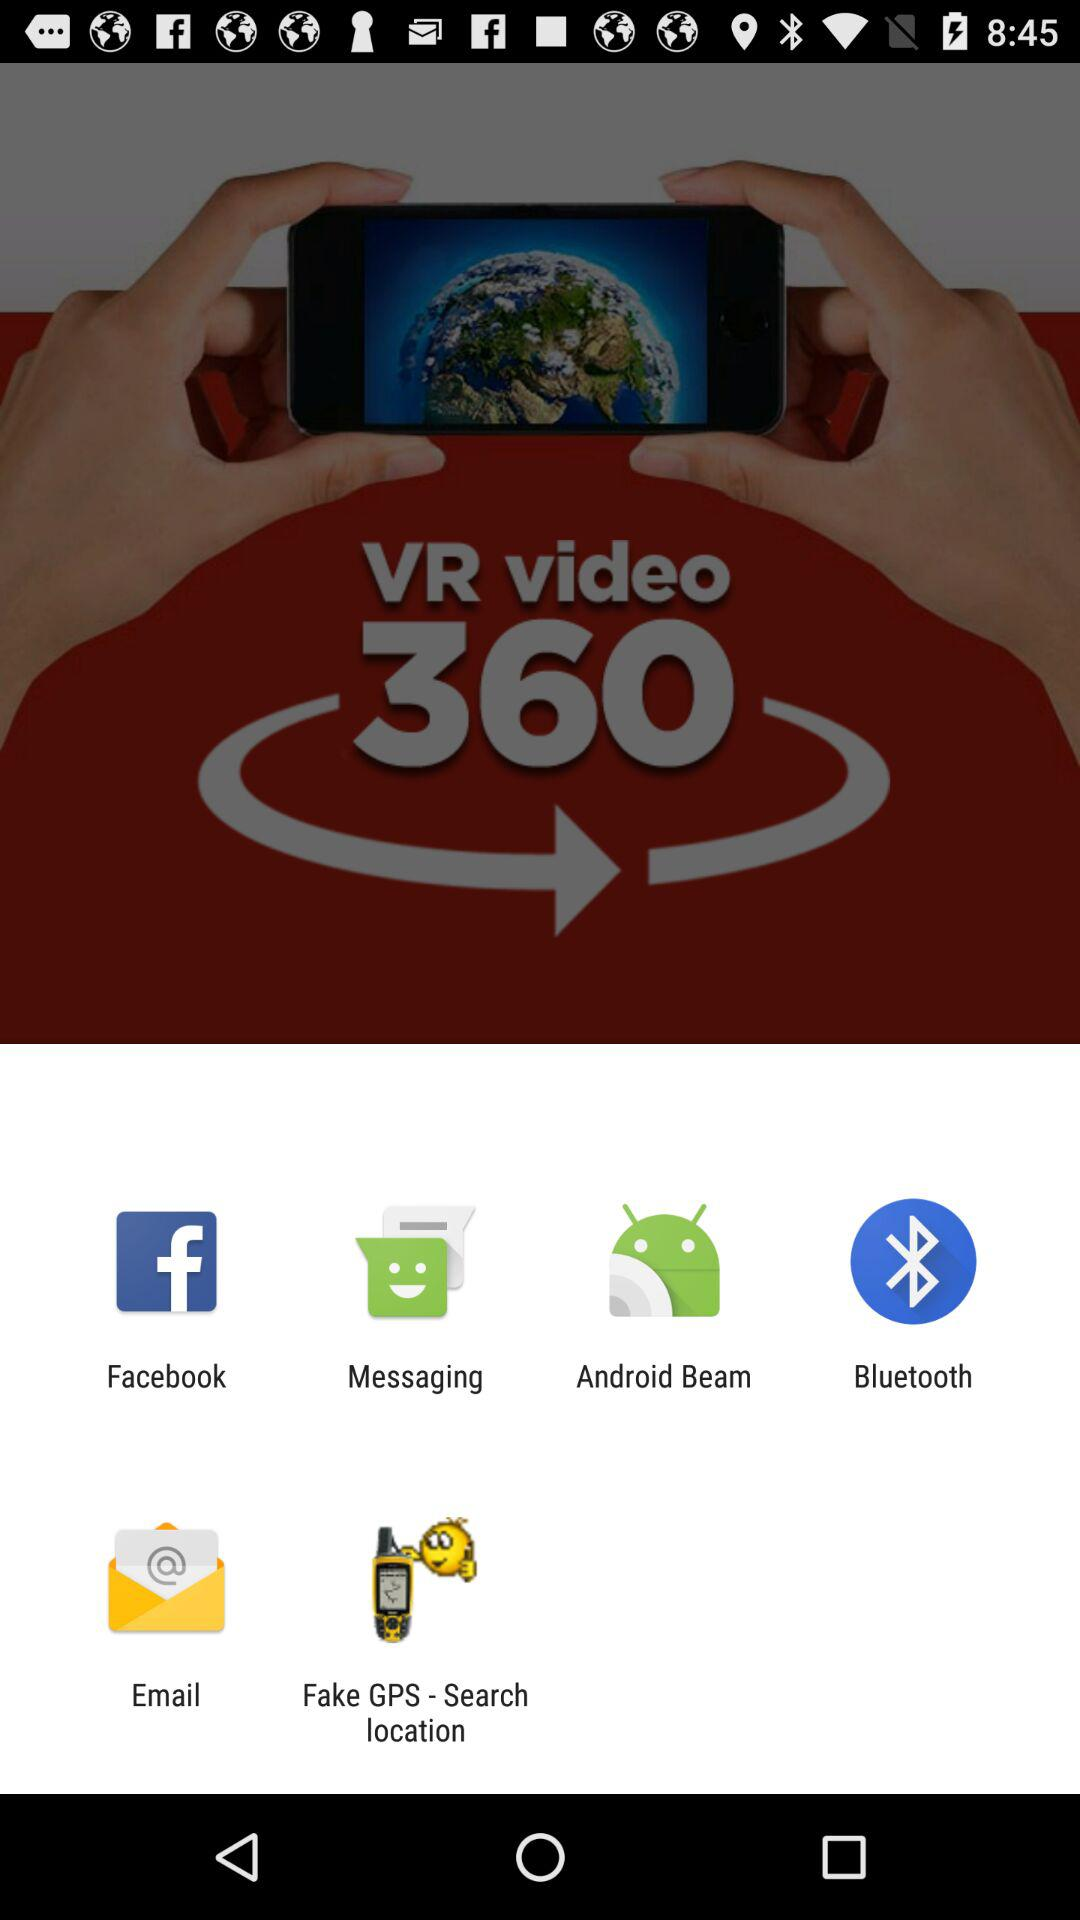Through which app can I share it? You can share it through "Facebook", "Messaging", "Android Beam", "Bluetooth", "Email" and "Fake GPS - Search location". 